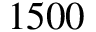Convert formula to latex. <formula><loc_0><loc_0><loc_500><loc_500>1 5 0 0</formula> 